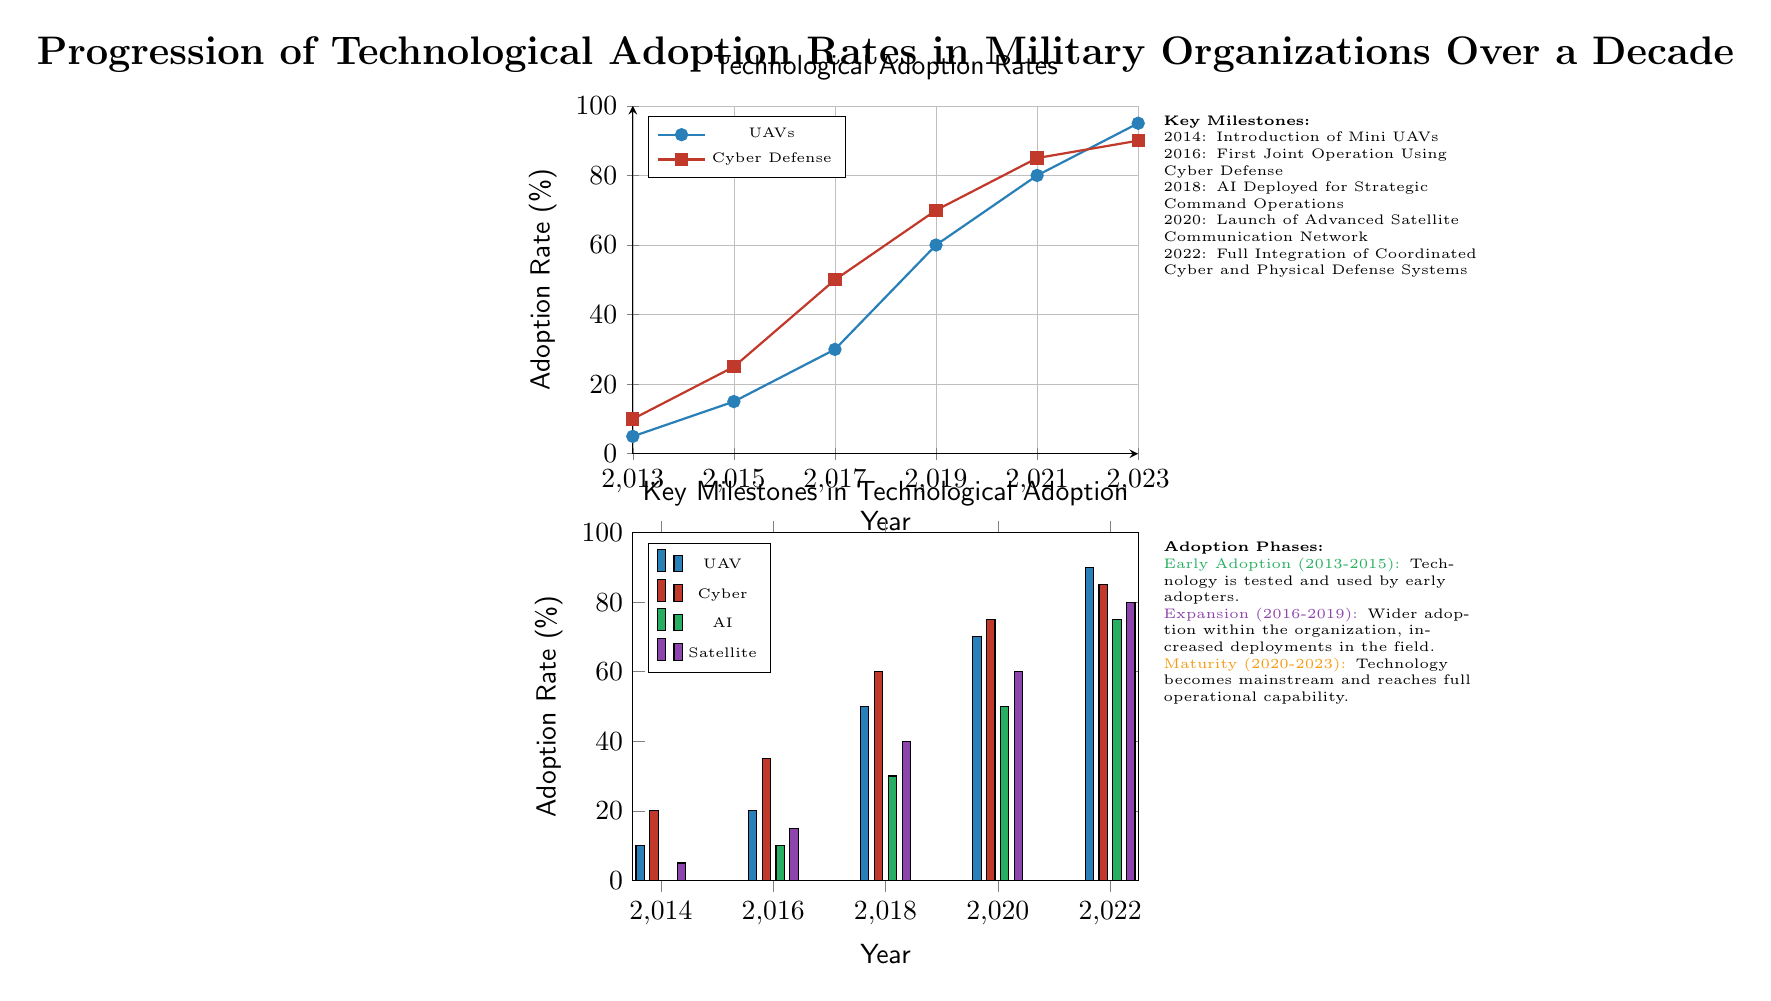What is the adoption rate of UAVs in 2021? In the line graph representing technological adoption rates, find the point for UAVs in the year 2021. The graph indicates that the adoption rate is 80%.
Answer: 80 What year did the Cyber Defense adoption rate reach 85%? Looking at the line graph, observe the adoption rates for Cyber Defense. It reaches 85% in the year 2021.
Answer: 2021 How many key milestones are illustrated in the diagram? The milestones section lists five entries detailing specific technological advancements over the years, thus there are five key milestones in total.
Answer: 5 In which phase did the first joint operation using Cyber Defense occur? Referring to the adoption phases indicated in the diagram, the first joint operation using Cyber Defense is noted to have happened during the Expansion phase (2016-2019).
Answer: Expansion What was the adoption rate of AI in 2020? In the bar chart for key milestones, identify the value for AI in 2020, which shows an adoption rate of 60%.
Answer: 60 Which technology had the highest adoption rate in 2023? Analyzing the line graphs, UAVs have an adoption rate of 95% in 2023, which is higher than all other technologies represented.
Answer: UAVs When was the launch of the Advanced Satellite Communication Network? The milestones section states that the launch of the Advanced Satellite Communication Network occurred in the year 2020.
Answer: 2020 What is the adoption rate for Cyber Defense in the year 2018? Looking at the bar chart, we can see the adoption rate for Cyber Defense in 2018 is labeled at 60%.
Answer: 60 During which adoption phase does technology achieve full operational capability? According to the adoption phases described, the Maturity phase (2020-2023) is where technology achieves full operational capability.
Answer: Maturity 